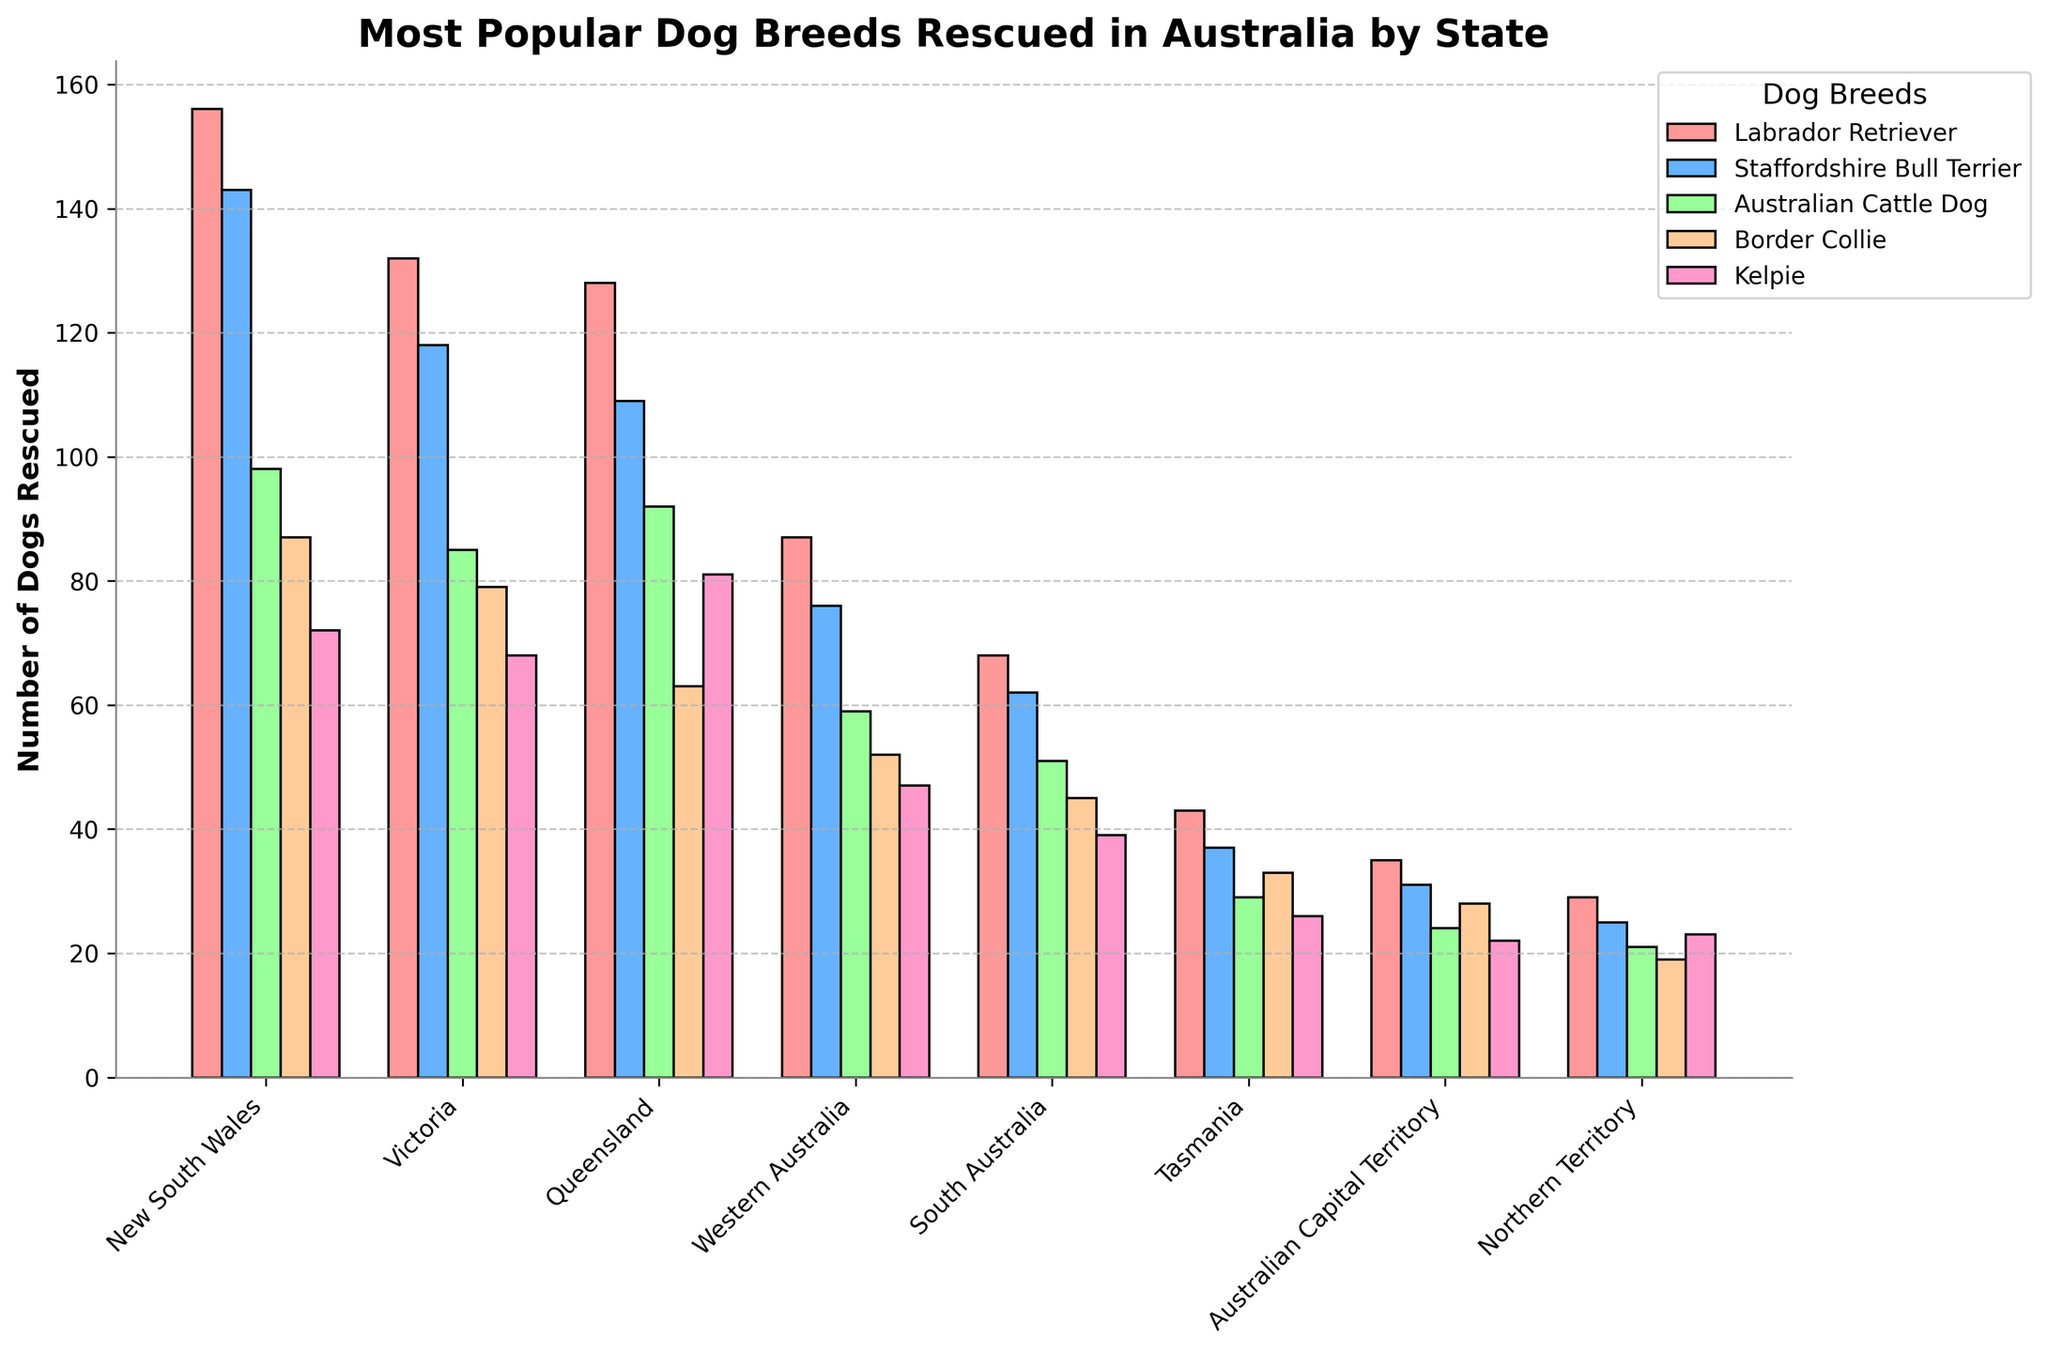Which state has the highest number of Labrador Retrievers rescued? By looking at the height of the bars for Labrador Retrievers in each state, the highest bar is for New South Wales, indicating it has the highest number of rescued Labrador Retrievers.
Answer: New South Wales Which state has the lowest number of Australian Cattle Dogs rescued? By comparing the height of all bars for Australian Cattle Dogs, the smallest bar belongs to Northern Territory.
Answer: Northern Territory How does the number of Kelpies rescued in Queensland compare with those in Victoria? The height of the bar for Kelpies in Queensland is taller than that in Victoria, indicating more Kelpies are rescued in Queensland.
Answer: Queensland > Victoria What's the total number of Staffordshire Bull Terriers rescued across all states? Sum the number of Staffordshire Bull Terriers rescued in each state: 143 (NSW) + 118 (VIC) + 109 (QLD) + 76 (WA) + 62 (SA) + 37 (TAS) + 31 (ACT) + 25 (NT) = 601.
Answer: 601 Compare the number of Border Collies rescued in New South Wales and South Australia. How much more are rescued in New South Wales? Subtract the number rescued in South Australia from those in New South Wales: 87 (NSW) - 45 (SA) = 42. There are 42 more rescued in New South Wales.
Answer: 42 Which breed is the most commonly rescued in Tasmania? By checking the highest bar in Tasmania's group, the Labrador Retriever has the highest bar, making it the most commonly rescued breed in Tasmania.
Answer: Labrador Retriever How does the number of dogs rescued in New South Wales compare to Victoria for the most popular breed in each state? The most popular breed in New South Wales is Labrador Retriever with 156, and in Victoria is also Labrador Retriever with 132. Since 156 is greater than 132, New South Wales rescued more of this breed.
Answer: New South Wales > Victoria How many more Border Collies are rescued in Victoria than in Tasmania? Subtract the number rescued in Tasmania from those in Victoria: 79 (VIC) - 33 (TAS) = 46. There are 46 more Border Collies rescued in Victoria.
Answer: 46 